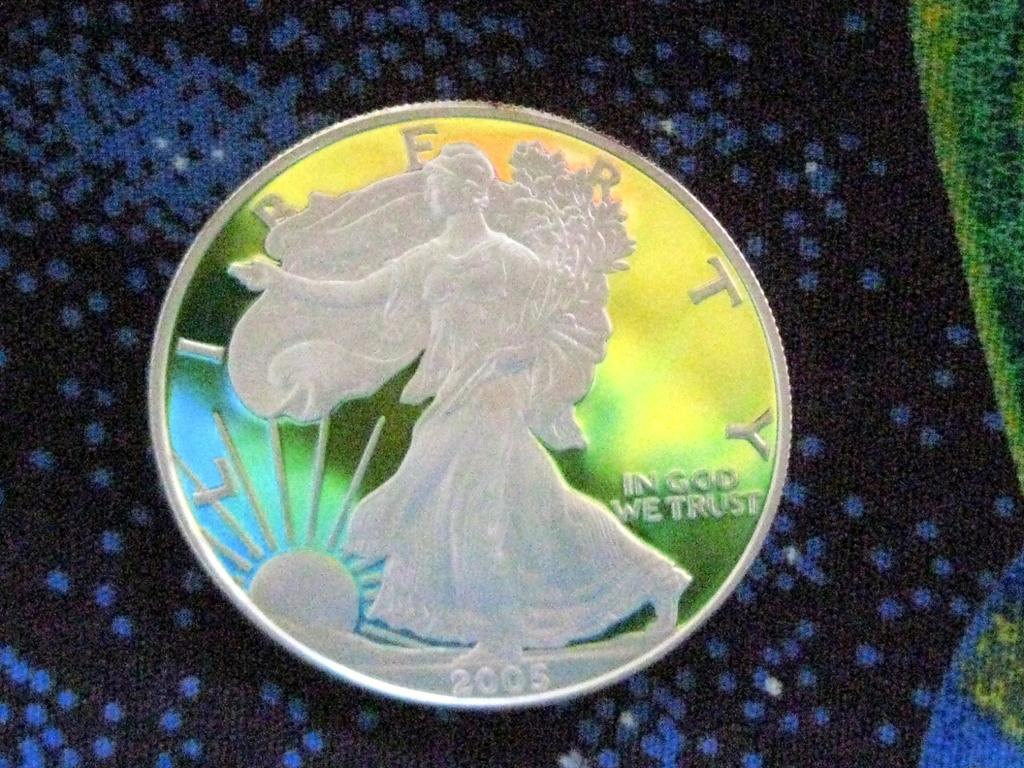<image>
Summarize the visual content of the image. A 2005 coin says Liberty and In God We Trust. 